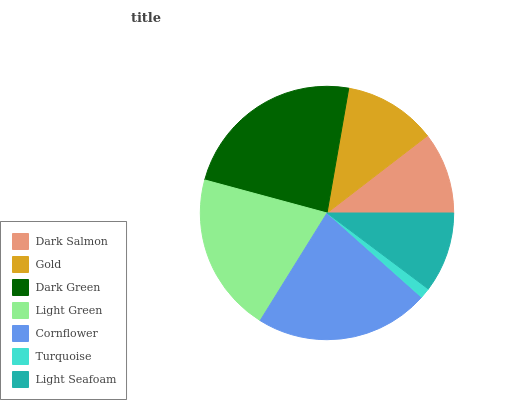Is Turquoise the minimum?
Answer yes or no. Yes. Is Dark Green the maximum?
Answer yes or no. Yes. Is Gold the minimum?
Answer yes or no. No. Is Gold the maximum?
Answer yes or no. No. Is Gold greater than Dark Salmon?
Answer yes or no. Yes. Is Dark Salmon less than Gold?
Answer yes or no. Yes. Is Dark Salmon greater than Gold?
Answer yes or no. No. Is Gold less than Dark Salmon?
Answer yes or no. No. Is Gold the high median?
Answer yes or no. Yes. Is Gold the low median?
Answer yes or no. Yes. Is Dark Green the high median?
Answer yes or no. No. Is Dark Green the low median?
Answer yes or no. No. 